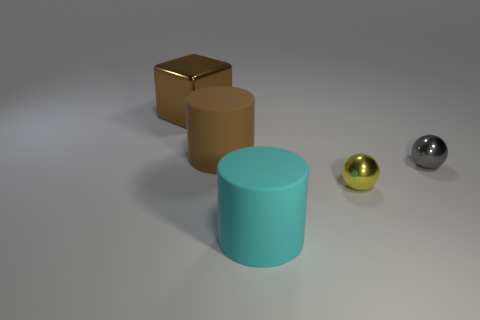Add 3 big purple shiny blocks. How many objects exist? 8 Subtract 2 cylinders. How many cylinders are left? 0 Subtract all cubes. How many objects are left? 4 Subtract all brown cylinders. How many cylinders are left? 1 Add 2 cylinders. How many cylinders are left? 4 Add 2 large things. How many large things exist? 5 Subtract 0 blue balls. How many objects are left? 5 Subtract all gray balls. Subtract all yellow cylinders. How many balls are left? 1 Subtract all green balls. How many green blocks are left? 0 Subtract all tiny metallic objects. Subtract all small things. How many objects are left? 1 